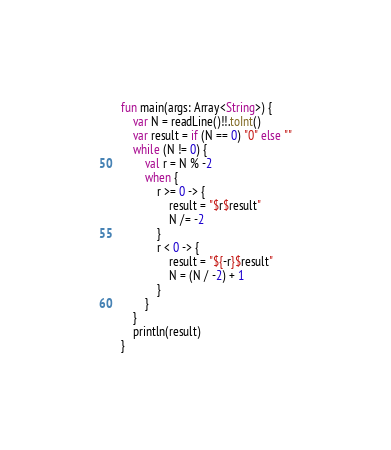Convert code to text. <code><loc_0><loc_0><loc_500><loc_500><_Kotlin_>fun main(args: Array<String>) {
    var N = readLine()!!.toInt()
    var result = if (N == 0) "0" else ""
    while (N != 0) {
        val r = N % -2
        when {
            r >= 0 -> {
                result = "$r$result"
                N /= -2
            }
            r < 0 -> {
                result = "${-r}$result"
                N = (N / -2) + 1
            }
        }
    }
    println(result)
}</code> 